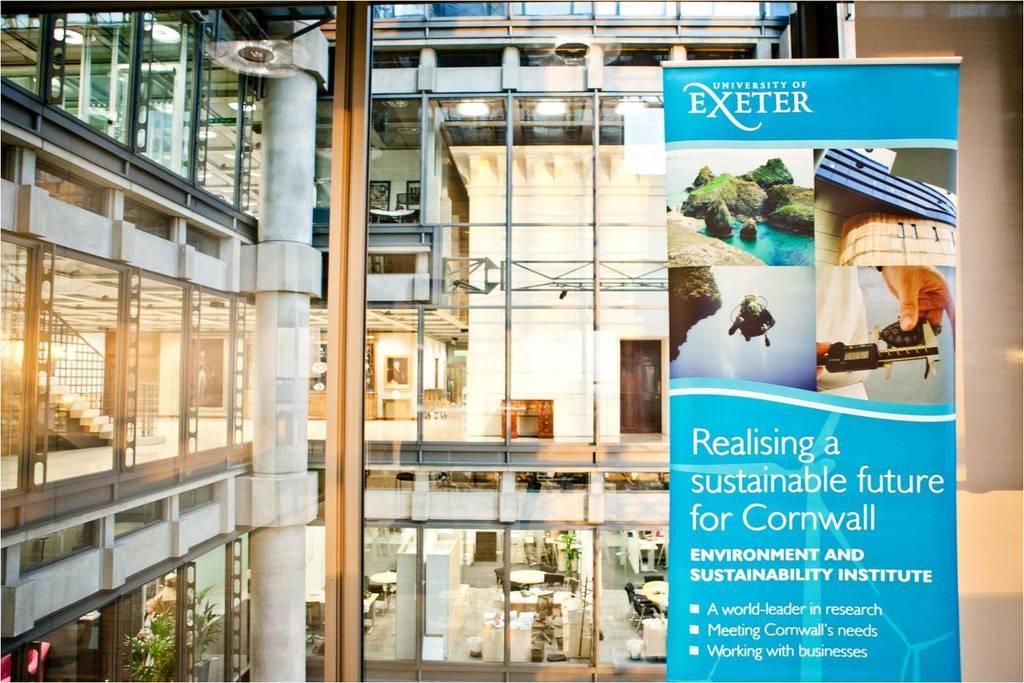Provide a one-sentence caption for the provided image. A brochure for the University of Exeter says Realising a sustainable future for Cornwall and is displayed in front of a building of glass windows. 